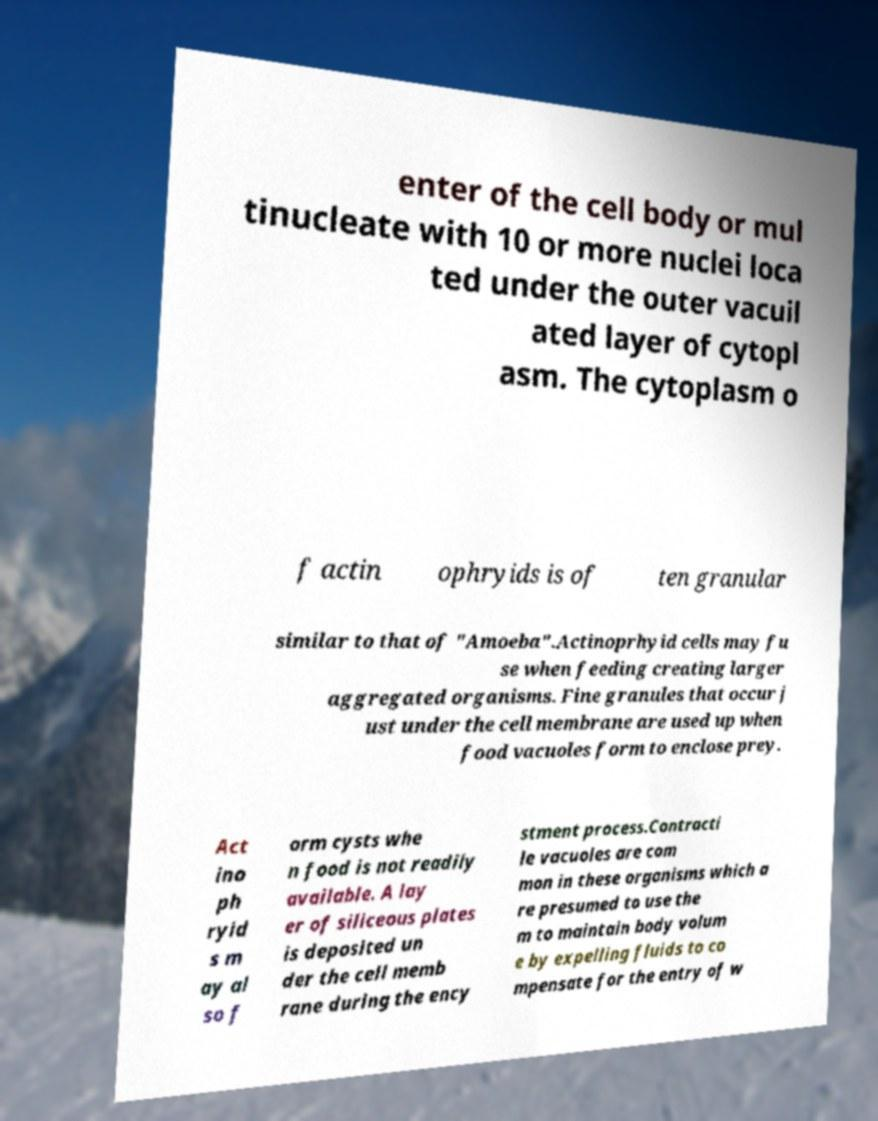For documentation purposes, I need the text within this image transcribed. Could you provide that? enter of the cell body or mul tinucleate with 10 or more nuclei loca ted under the outer vacuil ated layer of cytopl asm. The cytoplasm o f actin ophryids is of ten granular similar to that of "Amoeba".Actinoprhyid cells may fu se when feeding creating larger aggregated organisms. Fine granules that occur j ust under the cell membrane are used up when food vacuoles form to enclose prey. Act ino ph ryid s m ay al so f orm cysts whe n food is not readily available. A lay er of siliceous plates is deposited un der the cell memb rane during the ency stment process.Contracti le vacuoles are com mon in these organisms which a re presumed to use the m to maintain body volum e by expelling fluids to co mpensate for the entry of w 